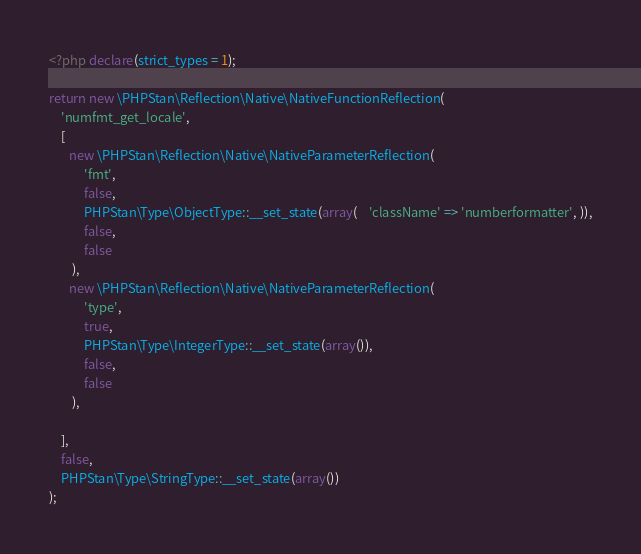Convert code to text. <code><loc_0><loc_0><loc_500><loc_500><_PHP_><?php declare(strict_types = 1);

return new \PHPStan\Reflection\Native\NativeFunctionReflection(
	'numfmt_get_locale',
	[
       new \PHPStan\Reflection\Native\NativeParameterReflection(
			'fmt',
			false,
			PHPStan\Type\ObjectType::__set_state(array(    'className' => 'numberformatter', )),
			false,
			false
		),
       new \PHPStan\Reflection\Native\NativeParameterReflection(
			'type',
			true,
			PHPStan\Type\IntegerType::__set_state(array()),
			false,
			false
		),

	],
	false,
	PHPStan\Type\StringType::__set_state(array())
);
</code> 